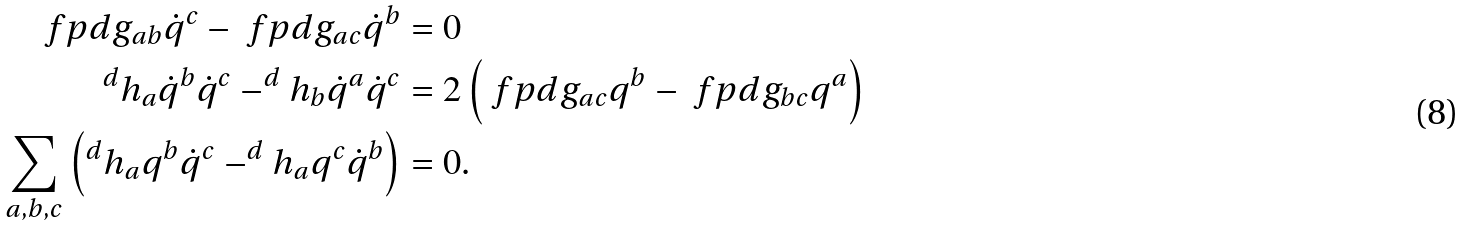<formula> <loc_0><loc_0><loc_500><loc_500>\ f p d { g _ { a b } } { \dot { q } ^ { c } } - \ f p d { g _ { a c } } { \dot { q } ^ { b } } & = 0 \\ ^ { d } { h _ { a } } { \dot { q } ^ { b } } { \dot { q } ^ { c } } - ^ { d } { h _ { b } } { \dot { q } ^ { a } } { \dot { q } ^ { c } } & = 2 \left ( \ f p d { g _ { a c } } { q ^ { b } } - \ f p d { g _ { b c } } { q ^ { a } } \right ) \\ \sum _ { a , b , c } \left ( ^ { d } { h _ { a } } { q ^ { b } } { \dot { q } ^ { c } } - ^ { d } { h _ { a } } { q ^ { c } } { \dot { q } ^ { b } } \right ) & = 0 .</formula> 